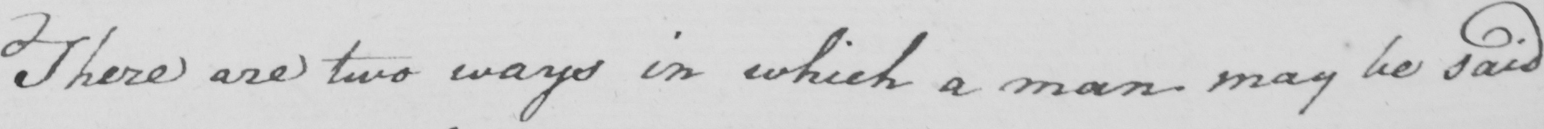Can you tell me what this handwritten text says? There are two ways in which a man may be said 